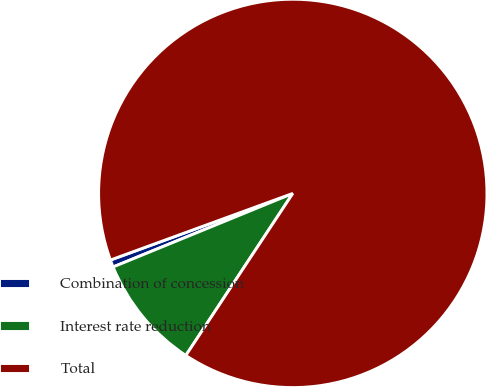Convert chart to OTSL. <chart><loc_0><loc_0><loc_500><loc_500><pie_chart><fcel>Combination of concession<fcel>Interest rate reduction<fcel>Total<nl><fcel>0.61%<fcel>9.53%<fcel>89.86%<nl></chart> 